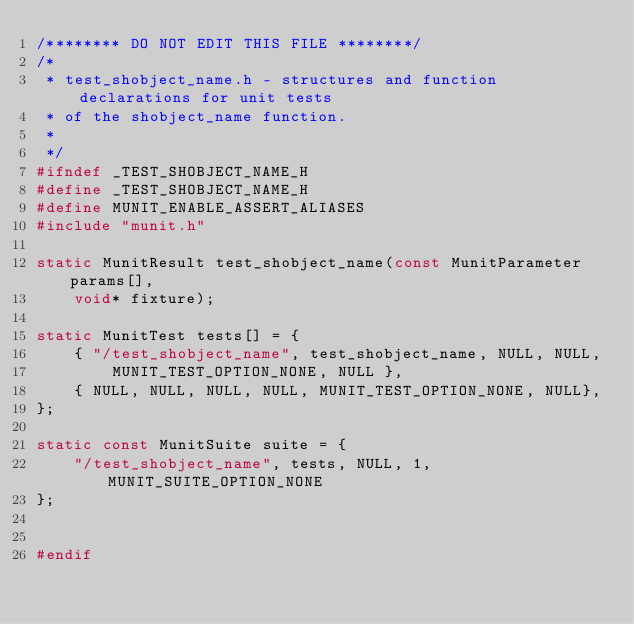<code> <loc_0><loc_0><loc_500><loc_500><_C_>/******** DO NOT EDIT THIS FILE ********/
/* 
 * test_shobject_name.h - structures and function declarations for unit tests
 * of the shobject_name function.
 * 
 */  
#ifndef _TEST_SHOBJECT_NAME_H
#define _TEST_SHOBJECT_NAME_H
#define MUNIT_ENABLE_ASSERT_ALIASES
#include "munit.h"

static MunitResult test_shobject_name(const MunitParameter params[],
    void* fixture);
    
static MunitTest tests[] = {
    { "/test_shobject_name", test_shobject_name, NULL, NULL,
        MUNIT_TEST_OPTION_NONE, NULL },
    { NULL, NULL, NULL, NULL, MUNIT_TEST_OPTION_NONE, NULL},
};

static const MunitSuite suite = {
    "/test_shobject_name", tests, NULL, 1, MUNIT_SUITE_OPTION_NONE 
};    


#endif</code> 